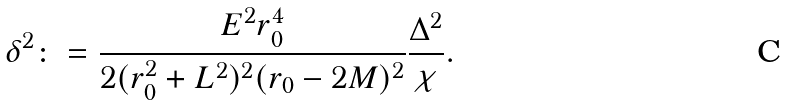Convert formula to latex. <formula><loc_0><loc_0><loc_500><loc_500>\delta ^ { 2 } \colon = \frac { E ^ { 2 } r _ { 0 } ^ { 4 } } { 2 ( r _ { 0 } ^ { 2 } + L ^ { 2 } ) ^ { 2 } ( r _ { 0 } - 2 M ) ^ { 2 } } \frac { \Delta ^ { 2 } } { \chi } .</formula> 